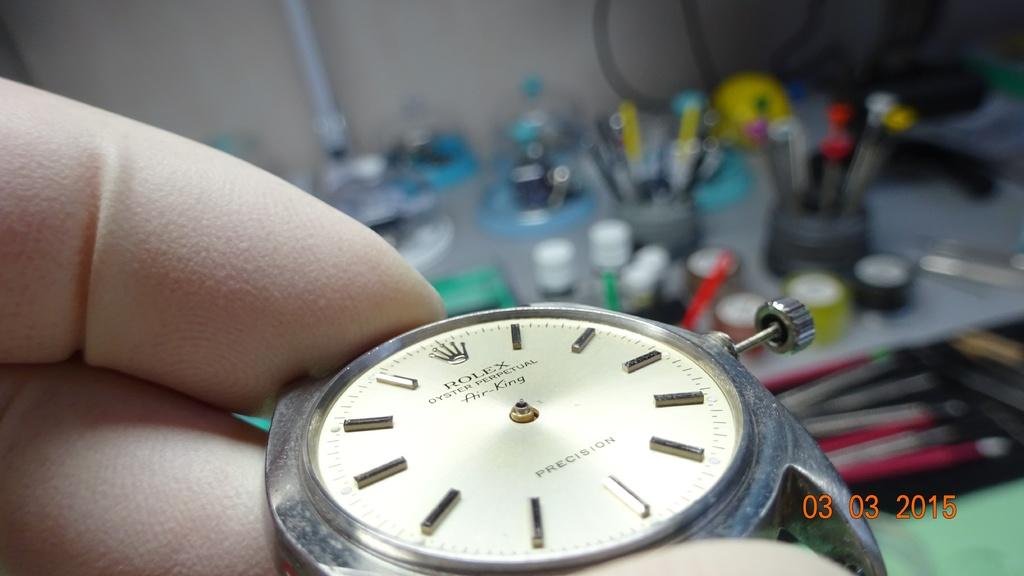What can be seen in the image? There is a person in the image. What is the person holding? The person is holding a watch. What is the color of the watch dial? The watch dial is in white color. Can you describe the background of the image? The background of the image is blurred. Are there any bricks visible in the image? No, there are no bricks present in the image. Can you see any people walking in the park in the image? There is no park or people walking in the image; it features a person holding a watch with a blurred background. 